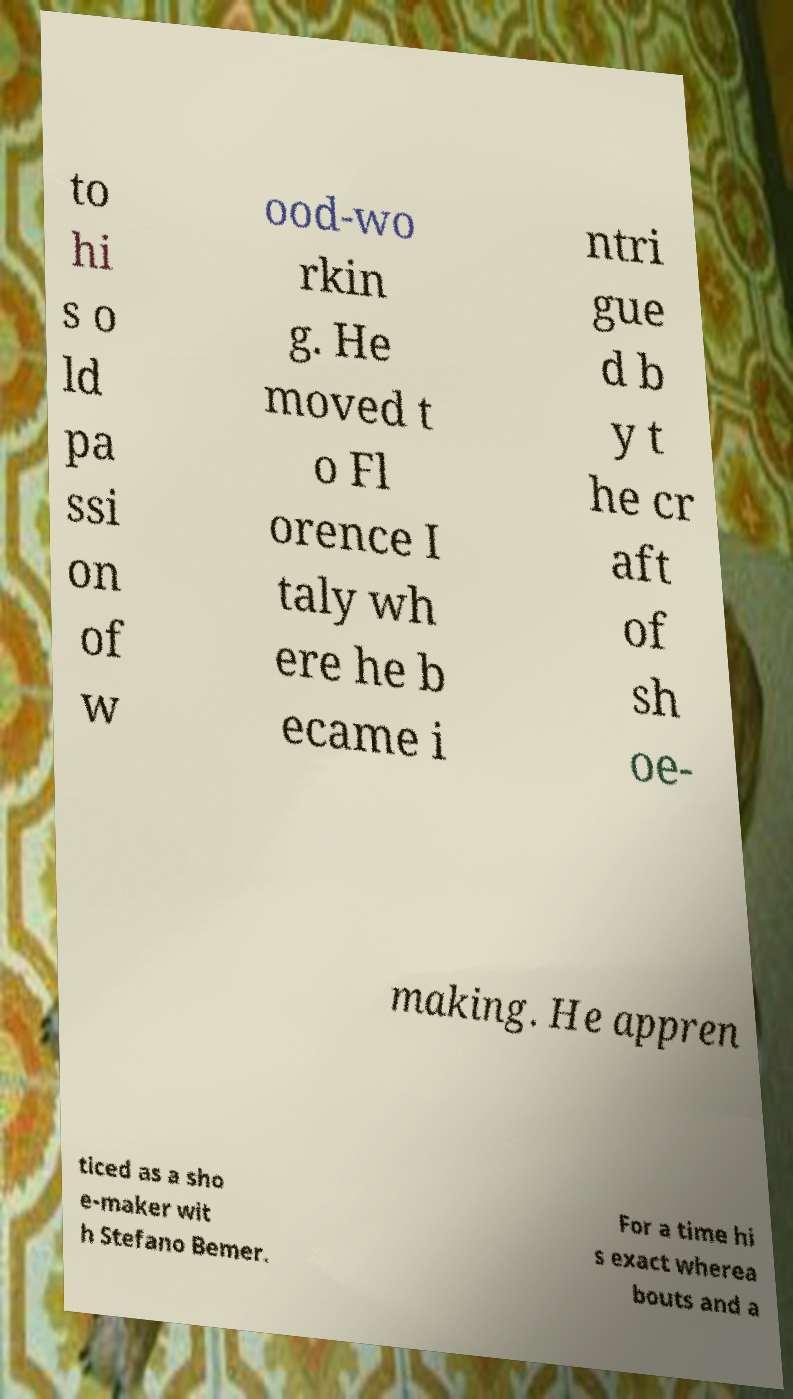I need the written content from this picture converted into text. Can you do that? to hi s o ld pa ssi on of w ood-wo rkin g. He moved t o Fl orence I taly wh ere he b ecame i ntri gue d b y t he cr aft of sh oe- making. He appren ticed as a sho e-maker wit h Stefano Bemer. For a time hi s exact wherea bouts and a 